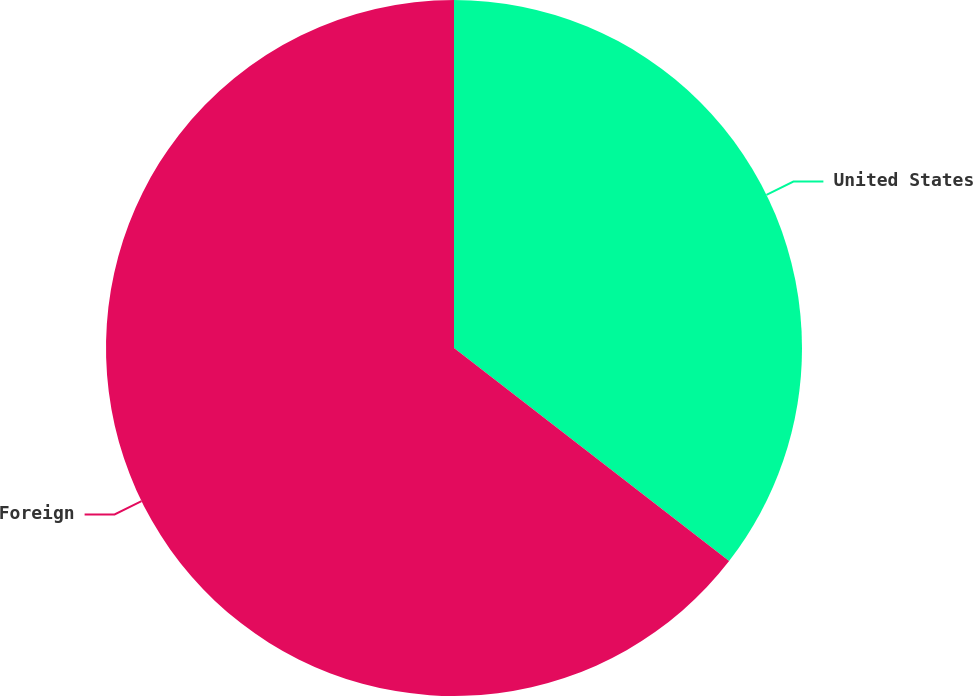<chart> <loc_0><loc_0><loc_500><loc_500><pie_chart><fcel>United States<fcel>Foreign<nl><fcel>35.49%<fcel>64.51%<nl></chart> 